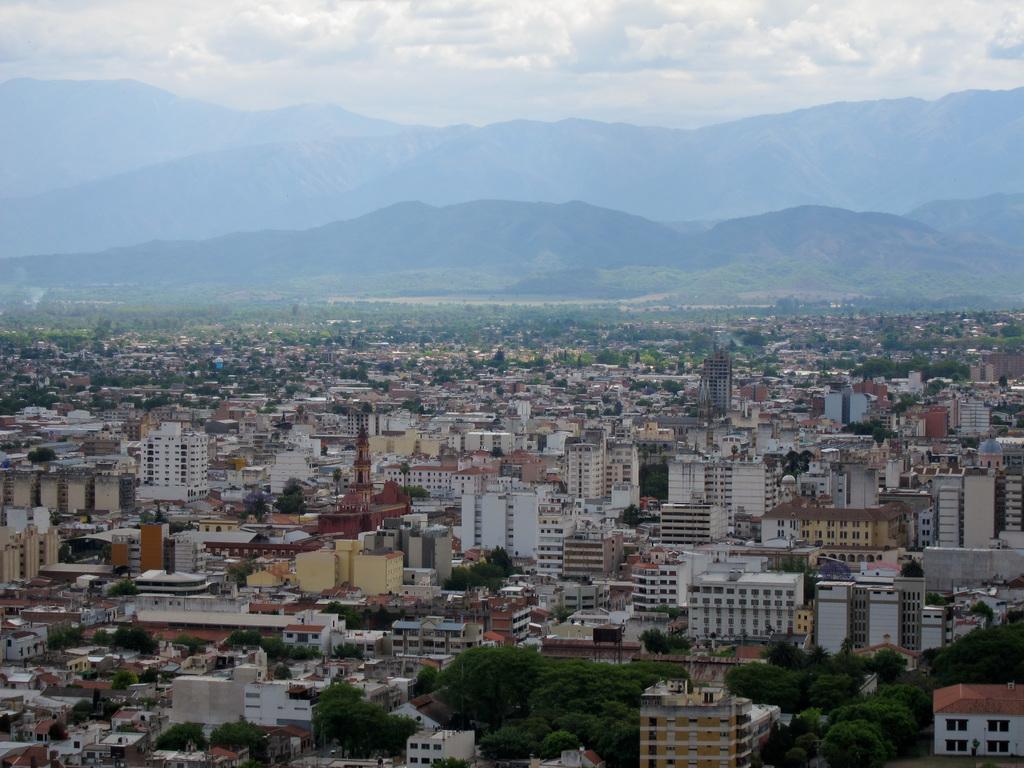How would you summarize this image in a sentence or two? In this picture I can observe building in the middle of the picture. In the background there are hills and some clouds in the sky. 